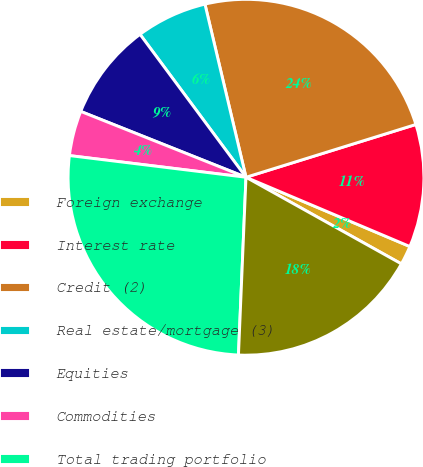Convert chart. <chart><loc_0><loc_0><loc_500><loc_500><pie_chart><fcel>Foreign exchange<fcel>Interest rate<fcel>Credit (2)<fcel>Real estate/mortgage (3)<fcel>Equities<fcel>Commodities<fcel>Total trading portfolio<fcel>Total market-based trading<nl><fcel>1.73%<fcel>11.16%<fcel>23.91%<fcel>6.45%<fcel>8.81%<fcel>4.09%<fcel>26.27%<fcel>17.58%<nl></chart> 